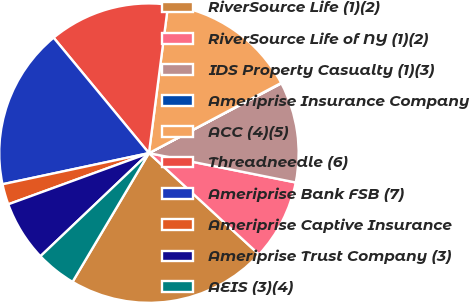<chart> <loc_0><loc_0><loc_500><loc_500><pie_chart><fcel>RiverSource Life (1)(2)<fcel>RiverSource Life of NY (1)(2)<fcel>IDS Property Casualty (1)(3)<fcel>Ameriprise Insurance Company<fcel>ACC (4)(5)<fcel>Threadneedle (6)<fcel>Ameriprise Bank FSB (7)<fcel>Ameriprise Captive Insurance<fcel>Ameriprise Trust Company (3)<fcel>AEIS (3)(4)<nl><fcel>21.68%<fcel>8.7%<fcel>10.86%<fcel>0.05%<fcel>15.19%<fcel>13.03%<fcel>17.35%<fcel>2.22%<fcel>6.54%<fcel>4.38%<nl></chart> 